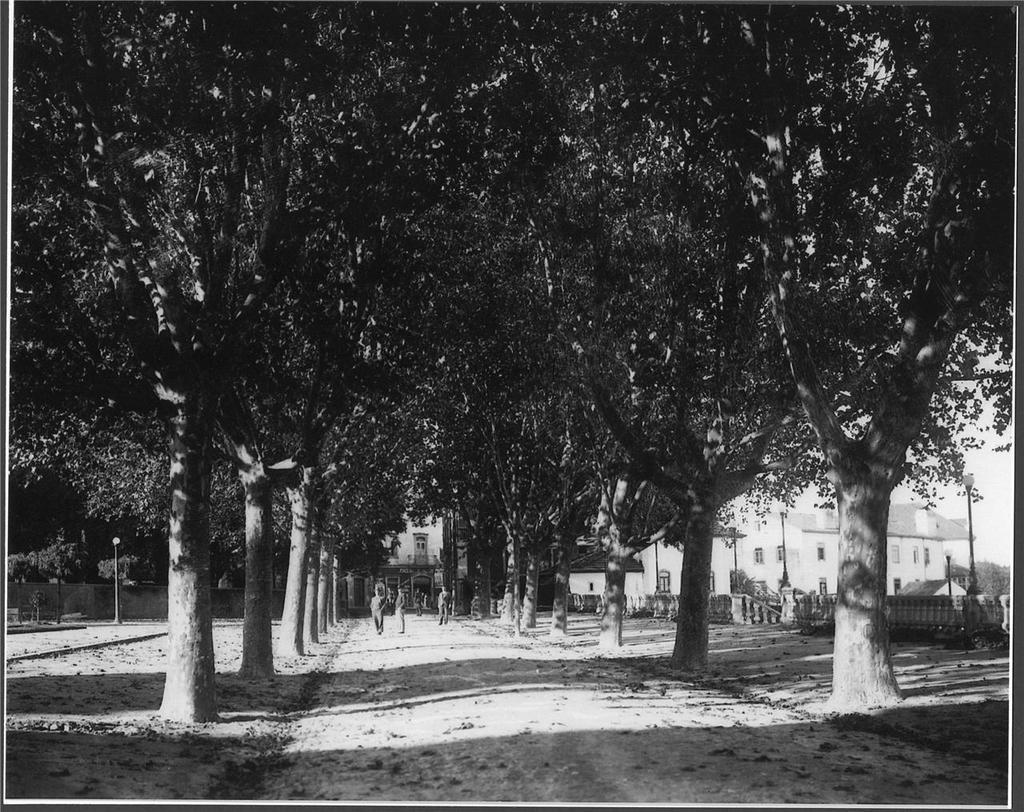What is the color scheme of the image? The image is black and white. How many people are in the image? There are three persons in the image. Where are the persons located in relation to the trees? The persons are between trees. What can be seen on the right side of the image? There are buildings on the right side of the image. What type of straw is being used by the persons in the image? There is no straw present in the image. How does the bath look like in the image? There is no bath present in the image. 